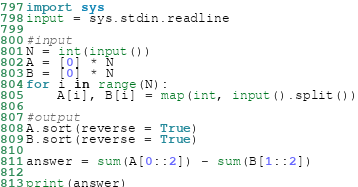Convert code to text. <code><loc_0><loc_0><loc_500><loc_500><_Python_>import sys
input = sys.stdin.readline

#input
N = int(input())
A = [0] * N
B = [0] * N
for i in range(N):
    A[i], B[i] = map(int, input().split())

#output
A.sort(reverse = True)
B.sort(reverse = True)

answer = sum(A[0::2]) - sum(B[1::2])

print(answer)
</code> 